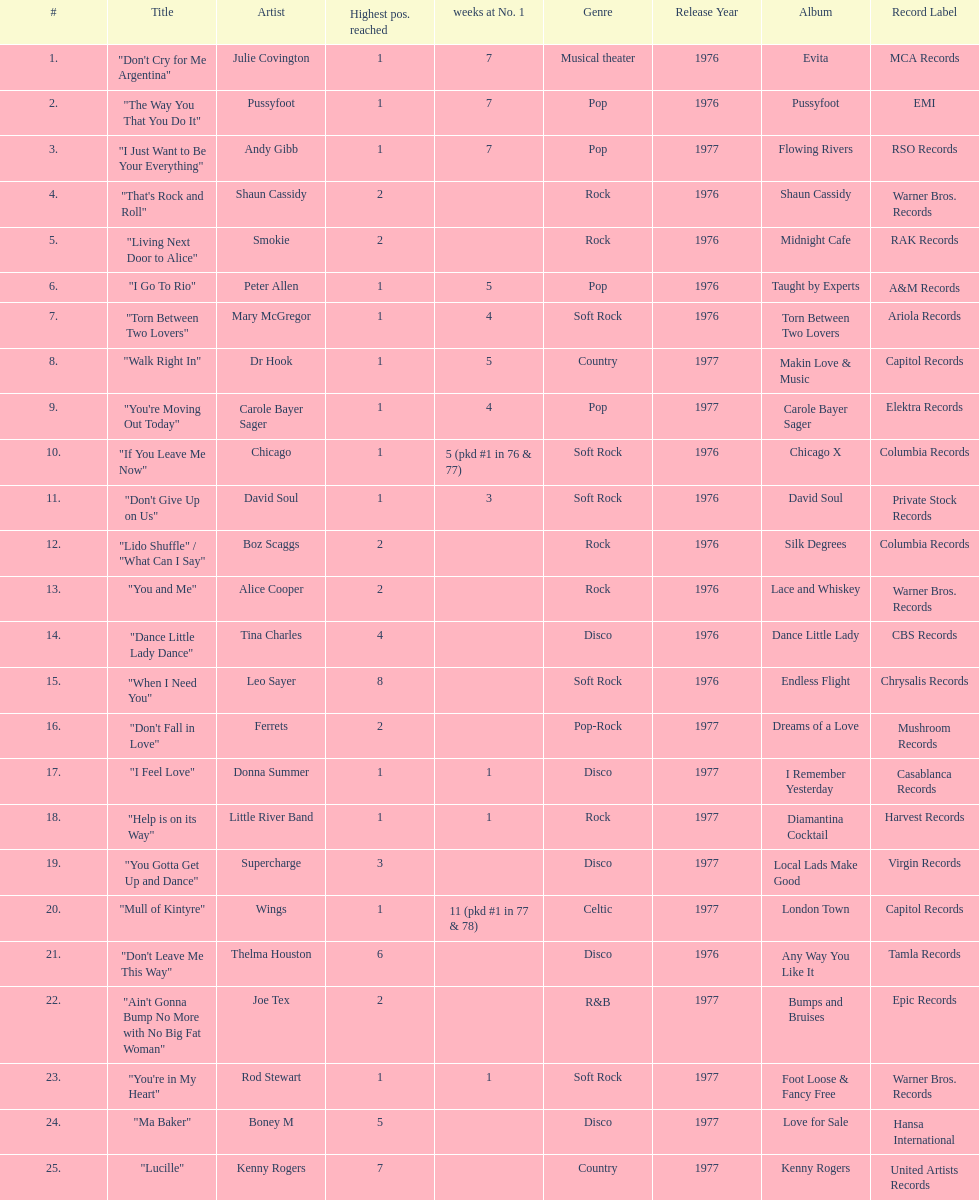How many weeks did julie covington's "don't cry for me argentina" spend at the top of australia's singles chart? 7. 